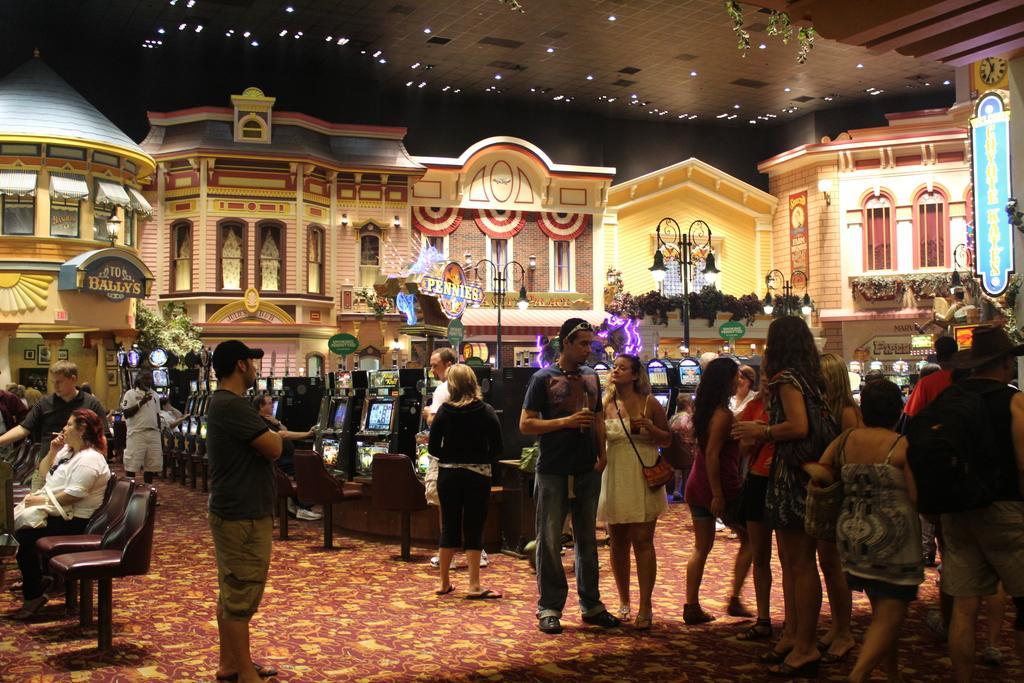Describe this image in one or two sentences. In this image we can see group of people standing on the floor. One women wearing white shirt is sitting on the chair with holding bag in her hand. In the background we can see group of buildings ,poles ,lights and gaming stations. 